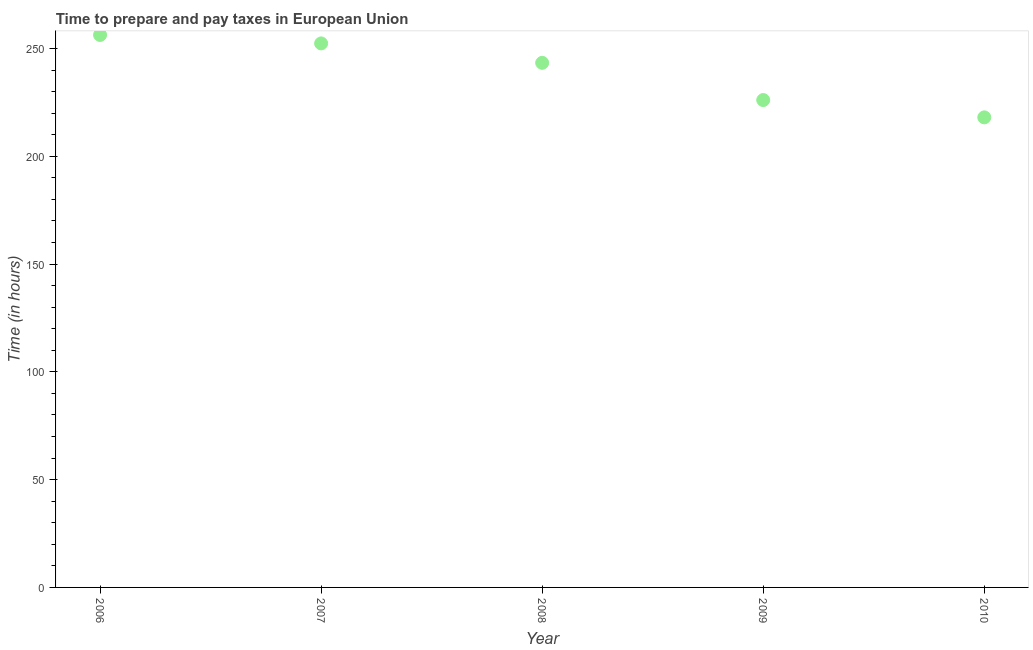What is the time to prepare and pay taxes in 2010?
Make the answer very short. 218.04. Across all years, what is the maximum time to prepare and pay taxes?
Offer a terse response. 256.27. Across all years, what is the minimum time to prepare and pay taxes?
Make the answer very short. 218.04. What is the sum of the time to prepare and pay taxes?
Provide a succinct answer. 1196.06. What is the difference between the time to prepare and pay taxes in 2009 and 2010?
Provide a succinct answer. 8.04. What is the average time to prepare and pay taxes per year?
Ensure brevity in your answer.  239.21. What is the median time to prepare and pay taxes?
Provide a short and direct response. 243.33. Do a majority of the years between 2006 and 2008 (inclusive) have time to prepare and pay taxes greater than 40 hours?
Keep it short and to the point. Yes. What is the ratio of the time to prepare and pay taxes in 2008 to that in 2009?
Make the answer very short. 1.08. Is the time to prepare and pay taxes in 2007 less than that in 2009?
Your answer should be very brief. No. Is the difference between the time to prepare and pay taxes in 2008 and 2010 greater than the difference between any two years?
Provide a succinct answer. No. What is the difference between the highest and the second highest time to prepare and pay taxes?
Keep it short and to the point. 3.92. What is the difference between the highest and the lowest time to prepare and pay taxes?
Your answer should be very brief. 38.23. In how many years, is the time to prepare and pay taxes greater than the average time to prepare and pay taxes taken over all years?
Your response must be concise. 3. Does the time to prepare and pay taxes monotonically increase over the years?
Offer a terse response. No. Are the values on the major ticks of Y-axis written in scientific E-notation?
Offer a very short reply. No. Does the graph contain any zero values?
Offer a very short reply. No. Does the graph contain grids?
Offer a very short reply. No. What is the title of the graph?
Offer a very short reply. Time to prepare and pay taxes in European Union. What is the label or title of the X-axis?
Your answer should be compact. Year. What is the label or title of the Y-axis?
Make the answer very short. Time (in hours). What is the Time (in hours) in 2006?
Keep it short and to the point. 256.27. What is the Time (in hours) in 2007?
Keep it short and to the point. 252.35. What is the Time (in hours) in 2008?
Your answer should be very brief. 243.33. What is the Time (in hours) in 2009?
Offer a very short reply. 226.07. What is the Time (in hours) in 2010?
Offer a terse response. 218.04. What is the difference between the Time (in hours) in 2006 and 2007?
Give a very brief answer. 3.92. What is the difference between the Time (in hours) in 2006 and 2008?
Provide a short and direct response. 12.94. What is the difference between the Time (in hours) in 2006 and 2009?
Provide a short and direct response. 30.2. What is the difference between the Time (in hours) in 2006 and 2010?
Provide a short and direct response. 38.23. What is the difference between the Time (in hours) in 2007 and 2008?
Give a very brief answer. 9.01. What is the difference between the Time (in hours) in 2007 and 2009?
Offer a terse response. 26.27. What is the difference between the Time (in hours) in 2007 and 2010?
Your answer should be compact. 34.31. What is the difference between the Time (in hours) in 2008 and 2009?
Ensure brevity in your answer.  17.26. What is the difference between the Time (in hours) in 2008 and 2010?
Make the answer very short. 25.3. What is the difference between the Time (in hours) in 2009 and 2010?
Make the answer very short. 8.04. What is the ratio of the Time (in hours) in 2006 to that in 2007?
Ensure brevity in your answer.  1.02. What is the ratio of the Time (in hours) in 2006 to that in 2008?
Make the answer very short. 1.05. What is the ratio of the Time (in hours) in 2006 to that in 2009?
Offer a terse response. 1.13. What is the ratio of the Time (in hours) in 2006 to that in 2010?
Offer a terse response. 1.18. What is the ratio of the Time (in hours) in 2007 to that in 2009?
Provide a short and direct response. 1.12. What is the ratio of the Time (in hours) in 2007 to that in 2010?
Offer a very short reply. 1.16. What is the ratio of the Time (in hours) in 2008 to that in 2009?
Your answer should be very brief. 1.08. What is the ratio of the Time (in hours) in 2008 to that in 2010?
Provide a short and direct response. 1.12. 